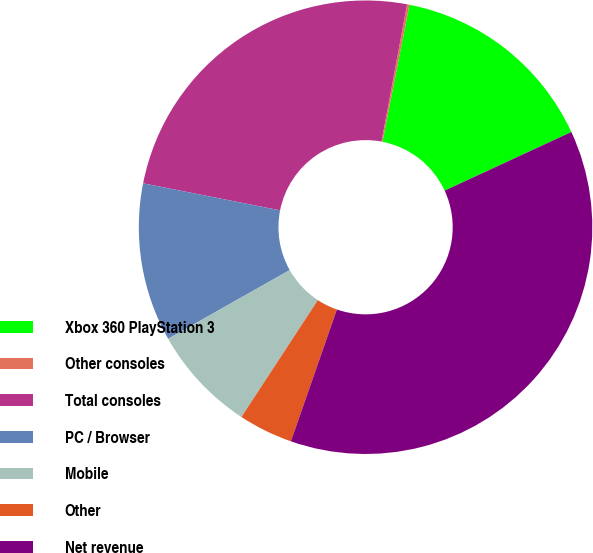Convert chart. <chart><loc_0><loc_0><loc_500><loc_500><pie_chart><fcel>Xbox 360 PlayStation 3<fcel>Other consoles<fcel>Total consoles<fcel>PC / Browser<fcel>Mobile<fcel>Other<fcel>Net revenue<nl><fcel>15.0%<fcel>0.17%<fcel>24.83%<fcel>11.29%<fcel>7.59%<fcel>3.88%<fcel>37.24%<nl></chart> 